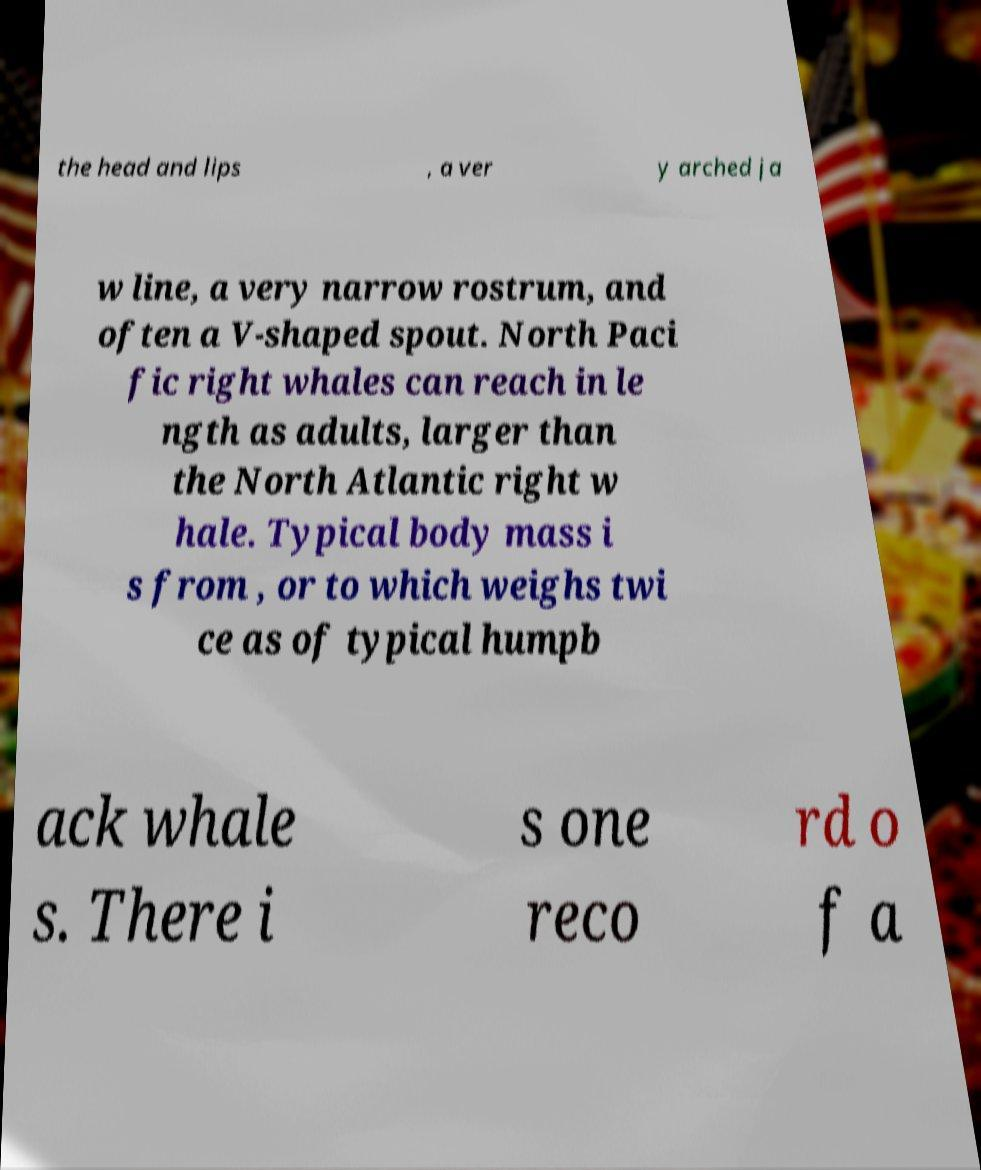I need the written content from this picture converted into text. Can you do that? the head and lips , a ver y arched ja w line, a very narrow rostrum, and often a V-shaped spout. North Paci fic right whales can reach in le ngth as adults, larger than the North Atlantic right w hale. Typical body mass i s from , or to which weighs twi ce as of typical humpb ack whale s. There i s one reco rd o f a 